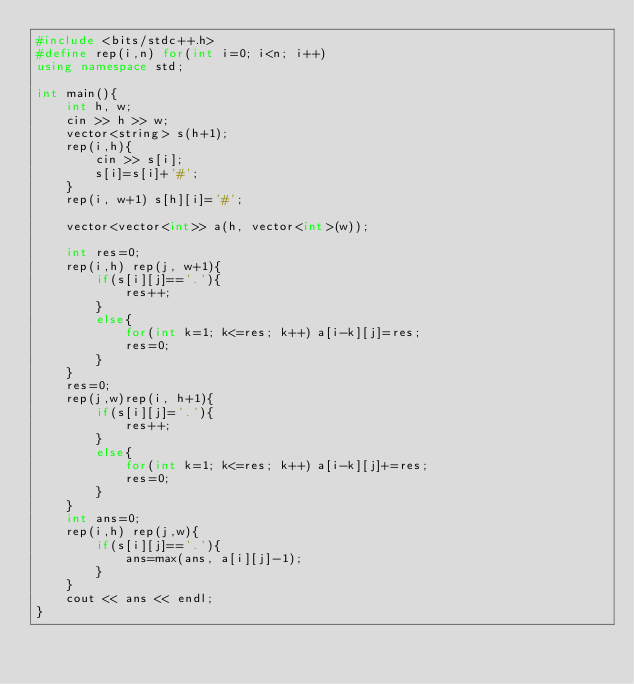Convert code to text. <code><loc_0><loc_0><loc_500><loc_500><_C++_>#include <bits/stdc++.h>
#define rep(i,n) for(int i=0; i<n; i++)
using namespace std;

int main(){
    int h, w;
    cin >> h >> w;
    vector<string> s(h+1); 
    rep(i,h){
        cin >> s[i];
        s[i]=s[i]+'#';
    }
    rep(i, w+1) s[h][i]='#';

    vector<vector<int>> a(h, vector<int>(w)); 

    int res=0; 
    rep(i,h) rep(j, w+1){
        if(s[i][j]=='.'){
            res++;
        }
        else{
            for(int k=1; k<=res; k++) a[i-k][j]=res;
            res=0; 
        }
    }
    res=0;
    rep(j,w)rep(i, h+1){ 
        if(s[i][j]='.'){
            res++;
        }
        else{
            for(int k=1; k<=res; k++) a[i-k][j]+=res;
            res=0;
        }
    }
    int ans=0;
    rep(i,h) rep(j,w){
        if(s[i][j]=='.'){
            ans=max(ans, a[i][j]-1);
        }
    }
    cout << ans << endl;
}</code> 